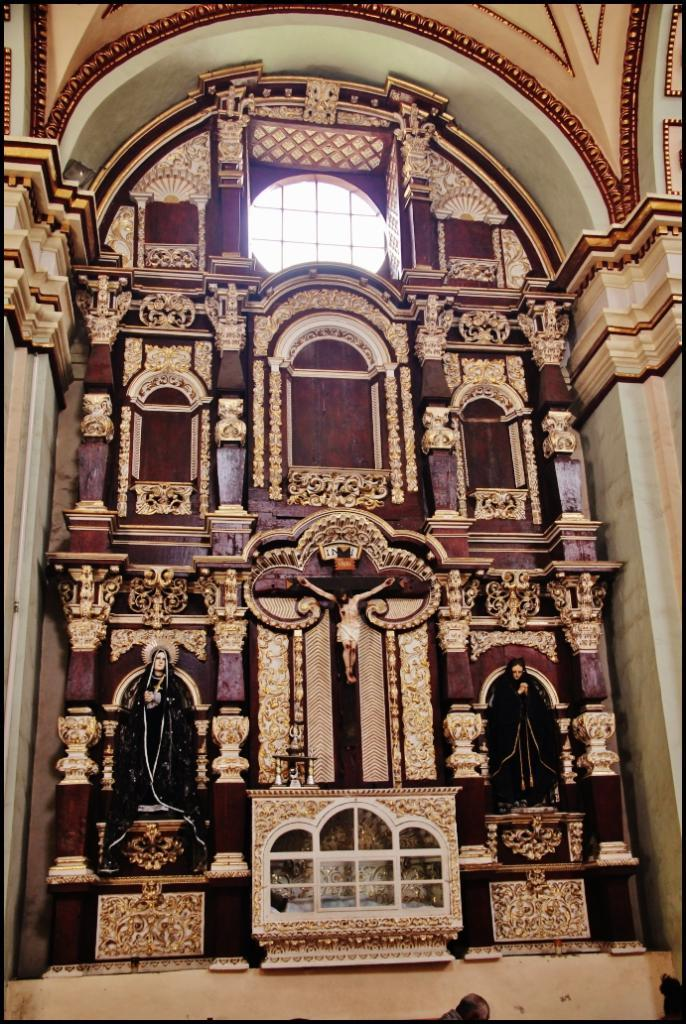What is the main subject in the center of the image? There is a statue in the center of the image. Are there any other statues visible in the image? Yes, there are statues on the right side and the left side of the image. What can be seen in the background of the image? There is a wall, pillars, and a window in the background of the image. Can you see any jellyfish swimming near the statues in the image? No, there are no jellyfish present in the image. Are there any babies playing near the statues in the image? No, there are no babies present in the image. 